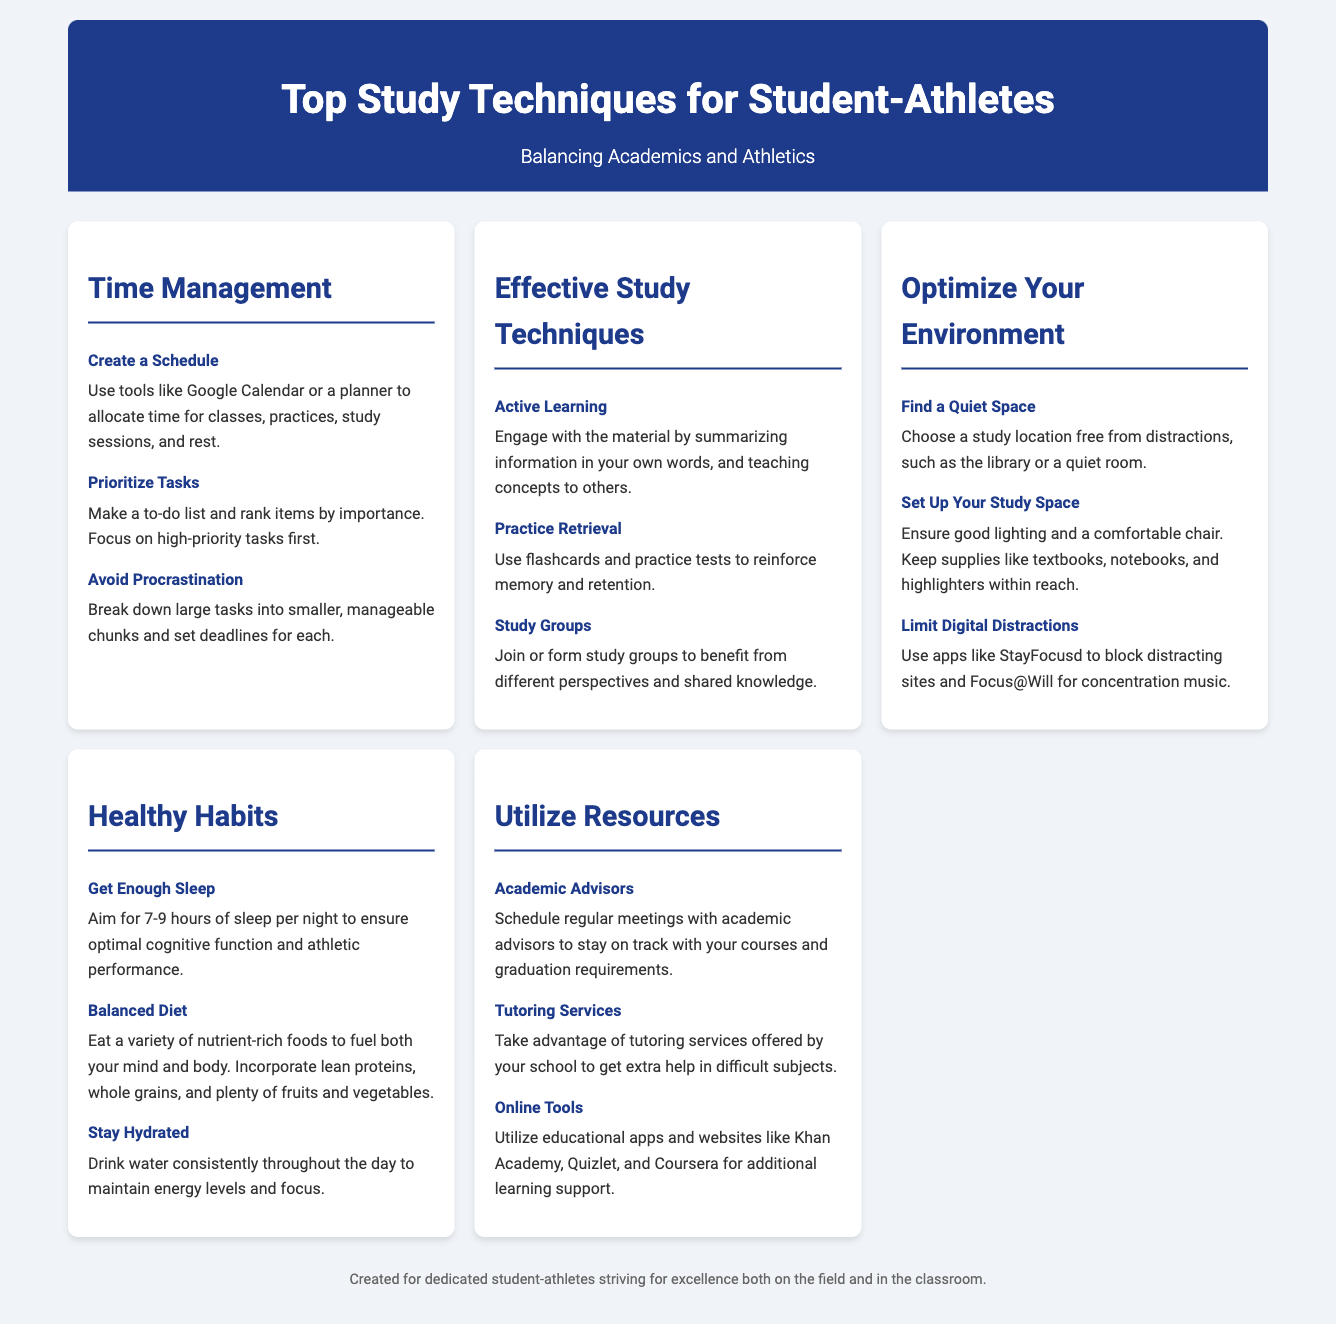What is the title of the infographic? The title of the infographic is clearly stated at the top of the document.
Answer: Top Study Techniques for Student-Athletes What are the four main categories covered in the infographic? Each category of study techniques is presented in separate sections.
Answer: Time Management, Effective Study Techniques, Optimize Your Environment, Healthy Habits, Utilize Resources How many hours of sleep should student-athletes aim for per night? This information is found under the Healthy Habits section.
Answer: 7-9 hours What is one tool recommended for creating a study schedule? The document highlights useful tools for managing time effectively.
Answer: Google Calendar What technique helps reinforce memory and retention? Referring to Effective Study Techniques, this technique is mentioned specifically for memorization.
Answer: Practice Retrieval Which section advises on the importance of finding a quiet space for studying? The section titled "Optimize Your Environment" discusses creating a conducive study atmosphere.
Answer: Optimize Your Environment What food types should be incorporated into a balanced diet? The details under Healthy Habits suggest the types of food for optimal performance.
Answer: Nutrient-rich foods Which service is suggested for getting extra help in difficult subjects? The Resources section mentions a specific service for academic support.
Answer: Tutoring Services What should be limited to avoid distractions while studying? The document emphasizes minimizing specific types of distractions in the study environment.
Answer: Digital Distractions 